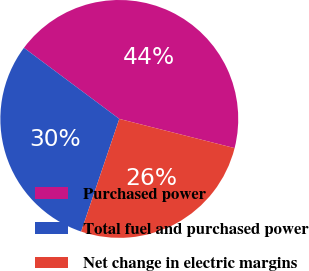<chart> <loc_0><loc_0><loc_500><loc_500><pie_chart><fcel>Purchased power<fcel>Total fuel and purchased power<fcel>Net change in electric margins<nl><fcel>43.75%<fcel>30.0%<fcel>26.25%<nl></chart> 